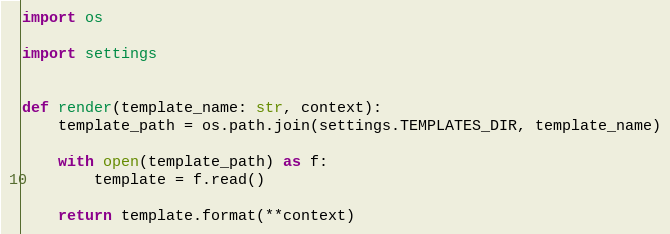Convert code to text. <code><loc_0><loc_0><loc_500><loc_500><_Python_>import os

import settings


def render(template_name: str, context):
    template_path = os.path.join(settings.TEMPLATES_DIR, template_name)

    with open(template_path) as f:
        template = f.read()

    return template.format(**context)
</code> 